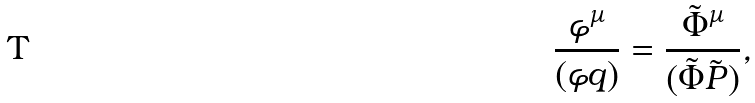Convert formula to latex. <formula><loc_0><loc_0><loc_500><loc_500>\frac { \varphi ^ { \mu } } { ( \varphi q ) } = \frac { \tilde { \Phi } ^ { \mu } } { ( \tilde { \Phi } \tilde { P } ) } ,</formula> 